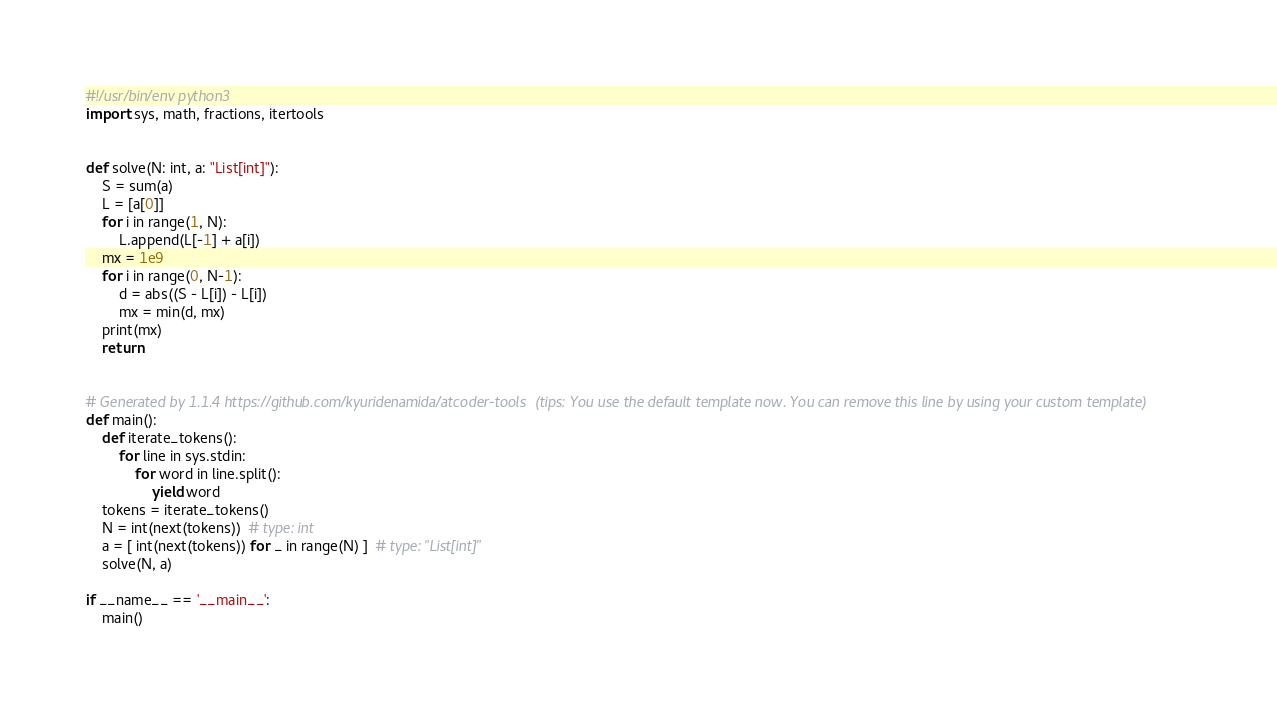Convert code to text. <code><loc_0><loc_0><loc_500><loc_500><_Python_>#!/usr/bin/env python3
import sys, math, fractions, itertools


def solve(N: int, a: "List[int]"):
    S = sum(a)
    L = [a[0]]
    for i in range(1, N):
        L.append(L[-1] + a[i])
    mx = 1e9
    for i in range(0, N-1):
        d = abs((S - L[i]) - L[i])
        mx = min(d, mx)
    print(mx)
    return


# Generated by 1.1.4 https://github.com/kyuridenamida/atcoder-tools  (tips: You use the default template now. You can remove this line by using your custom template)
def main():
    def iterate_tokens():
        for line in sys.stdin:
            for word in line.split():
                yield word
    tokens = iterate_tokens()
    N = int(next(tokens))  # type: int
    a = [ int(next(tokens)) for _ in range(N) ]  # type: "List[int]"
    solve(N, a)

if __name__ == '__main__':
    main()
</code> 